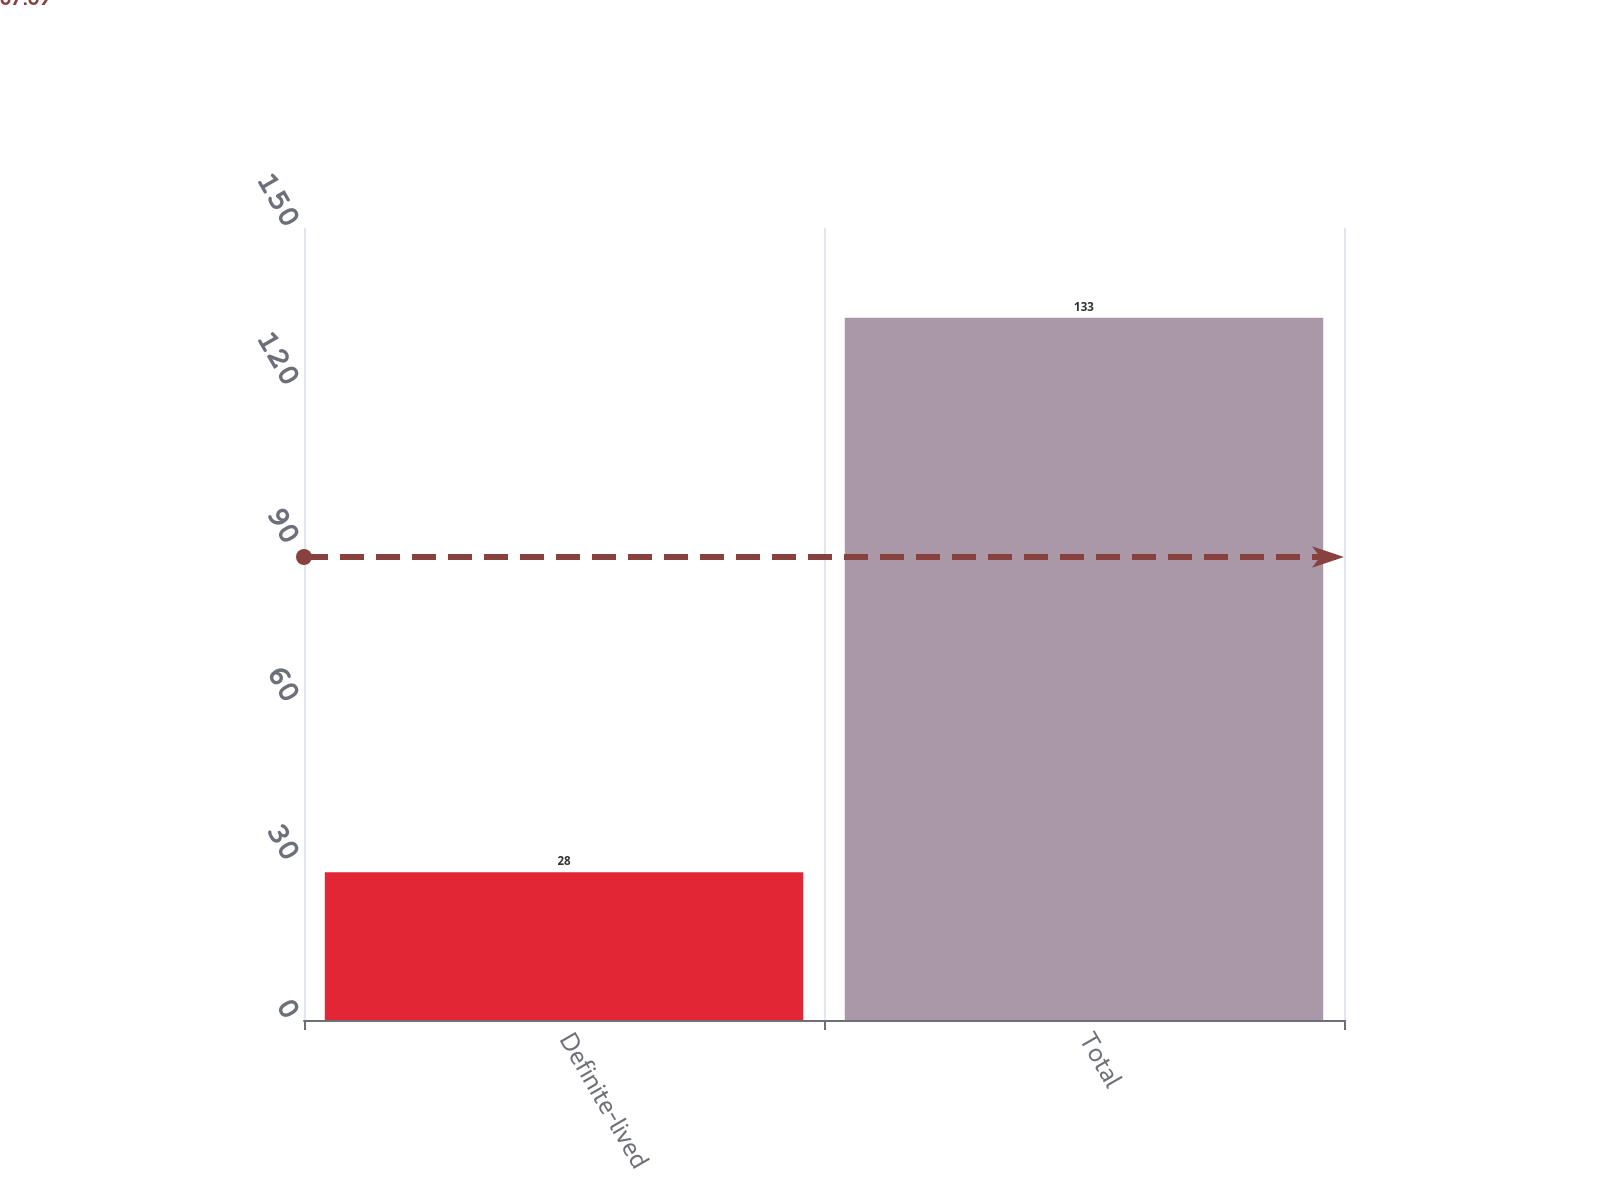Convert chart to OTSL. <chart><loc_0><loc_0><loc_500><loc_500><bar_chart><fcel>Definite-lived<fcel>Total<nl><fcel>28<fcel>133<nl></chart> 